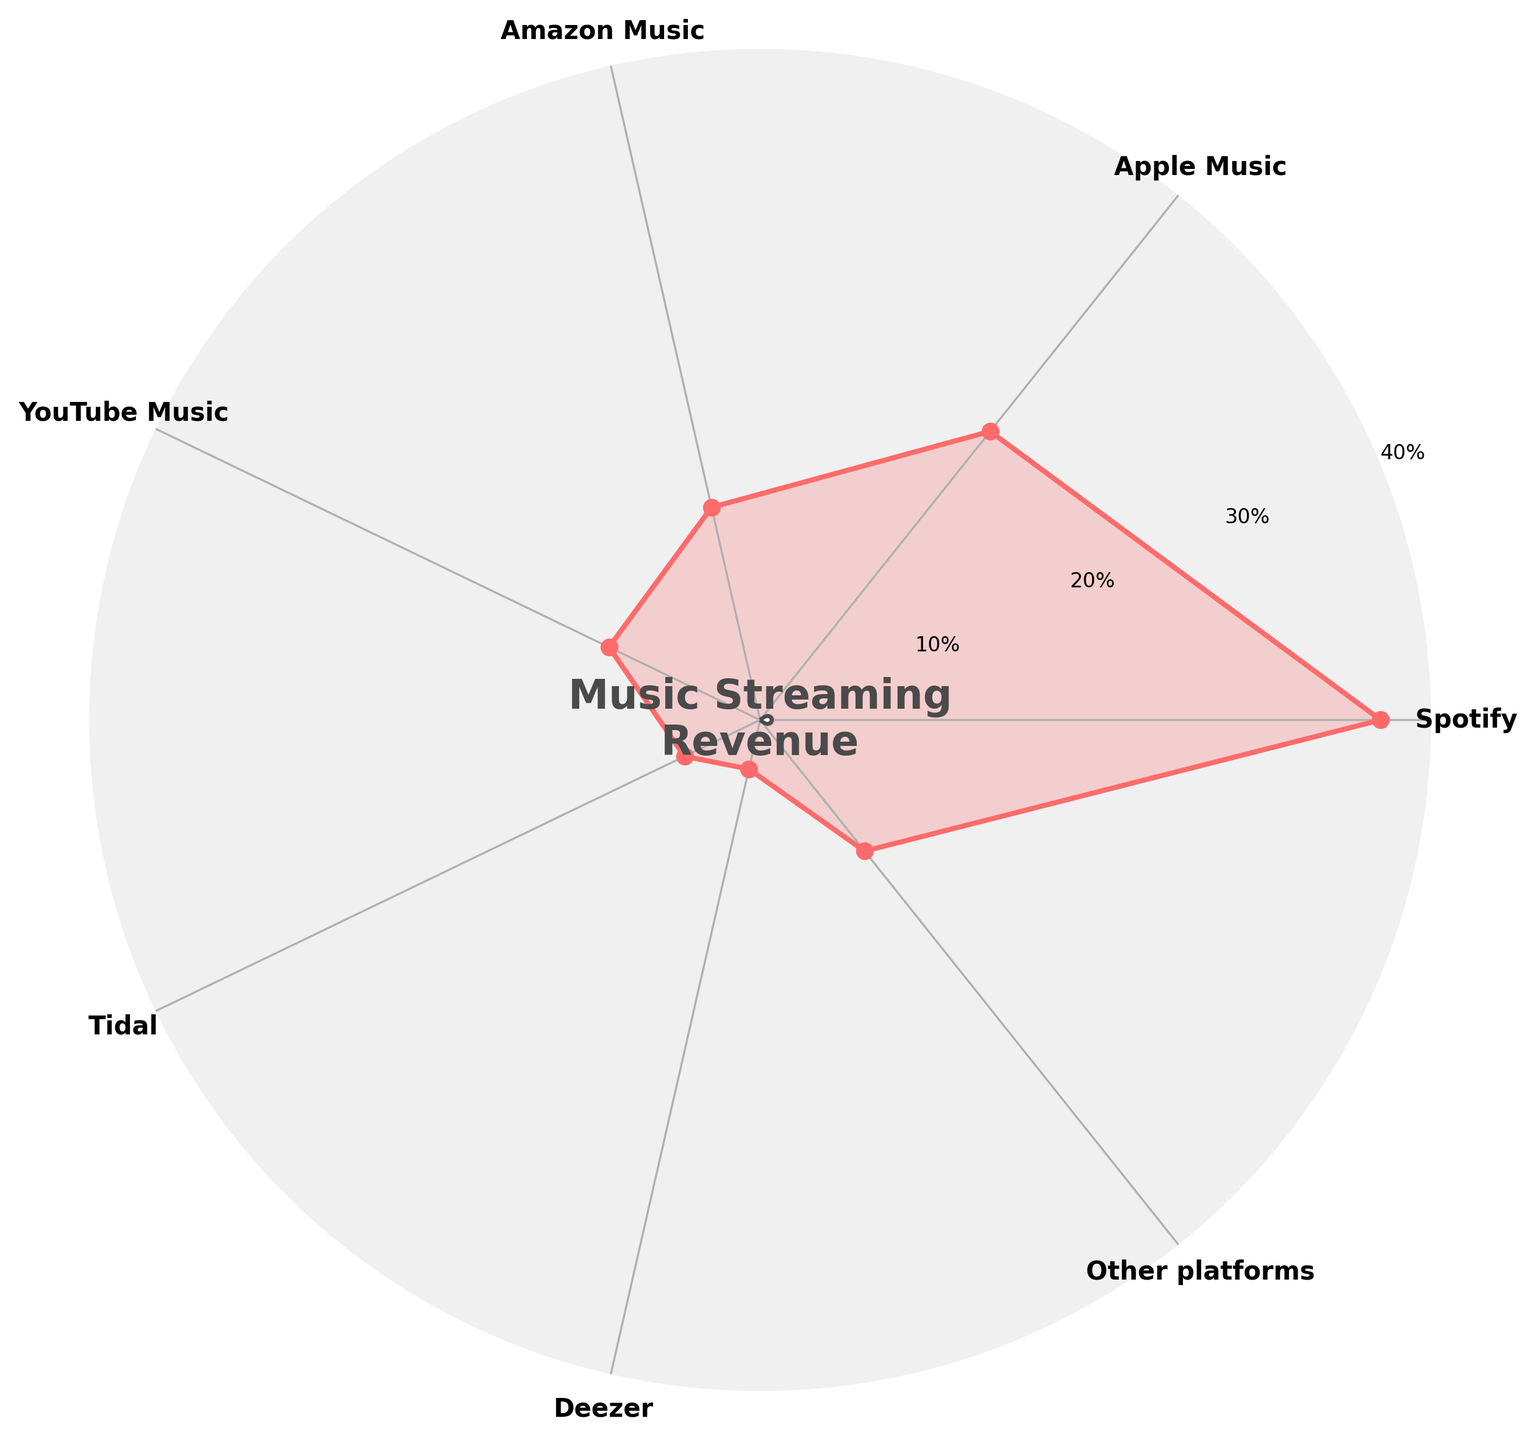What is the title of the figure? The title is positioned at the center of the gauge chart and reads "Music Streaming\nRevenue".
Answer: Music Streaming Revenue How many categories are represented in the gauge chart? There are labels placed at intervals on the edges of the chart. Counting these labels provides the total number of categories.
Answer: 7 Which streaming platform generates the highest percentage of music revenue? From the labels and values shown, we identify the segment with the highest value. The segment labeled "Spotify" has the highest value of 37%.
Answer: Spotify What percentage of music revenue comes from Apple Music and Amazon Music combined? By examining the segments labeled "Apple Music" and "Amazon Music", we add their respective values: 22% and 13%, providing the combined value.
Answer: 35% Which streaming platform contributes the least to music revenue? Comparing the values of each labeled segment, the platform "Deezer" has the lowest percentage value of 3%.
Answer: Deezer Is the revenue contribution from Tidal larger than YouTube Music? Comparing the values of the segments labeled "Tidal" (5%) and "YouTube Music" (10%), YouTube Music has a higher percentage than Tidal.
Answer: No What is the average percentage of revenue from Spotify, Apple Music, and Amazon Music? We sum the values of "Spotify" (37%), "Apple Music" (22%), and "Amazon Music" (13%) to get 72%, and then divide by the number of platforms which is 3.
Answer: 24% How much higher is the percentage for Spotify compared to Deezer? Subtracting the percentage value for Deezer (3%) from that of Spotify (37%) gives the difference.
Answer: 34% Is the combined percentage of Amazon Music and Other platforms higher than the value for Spotify? Adding the percentages for "Amazon Music" (13%) and "Other platforms" (10%) results in 23%, which is less than the 37% for "Spotify".
Answer: No 